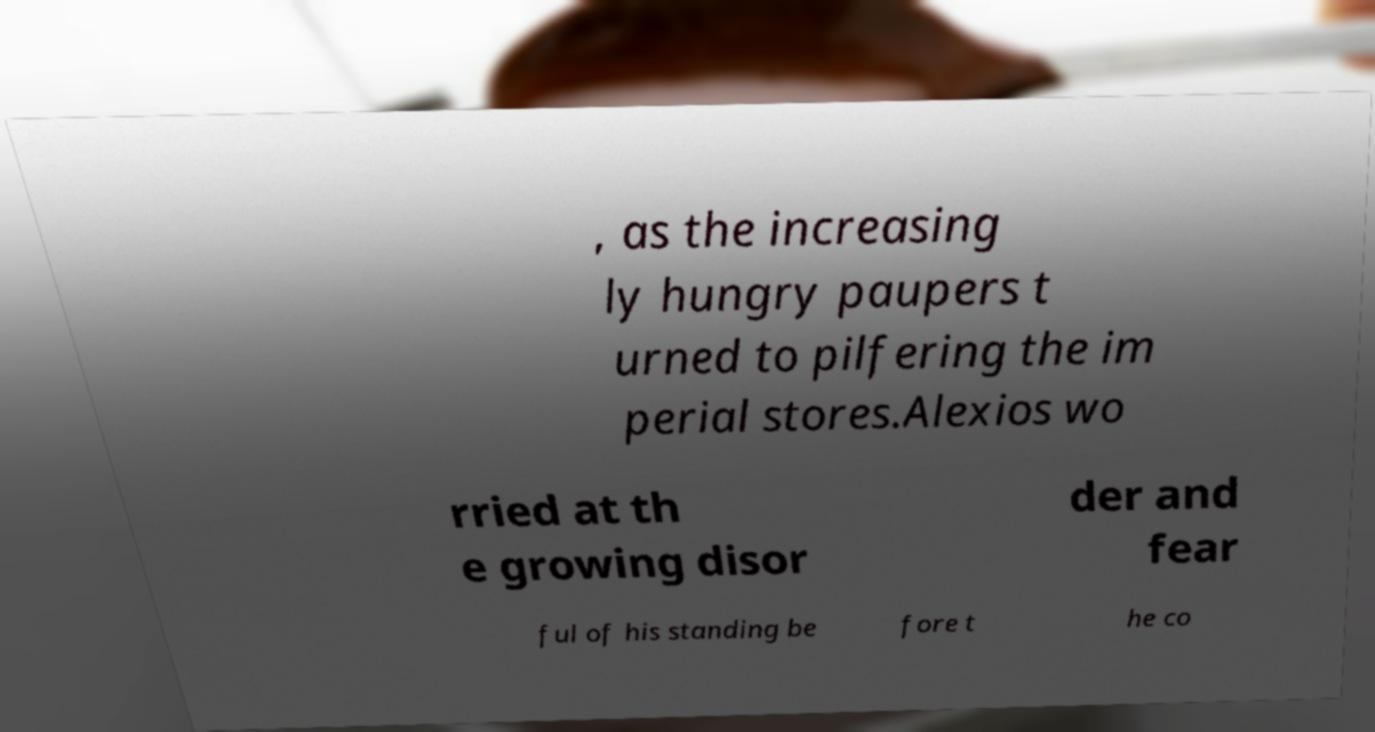Can you accurately transcribe the text from the provided image for me? , as the increasing ly hungry paupers t urned to pilfering the im perial stores.Alexios wo rried at th e growing disor der and fear ful of his standing be fore t he co 